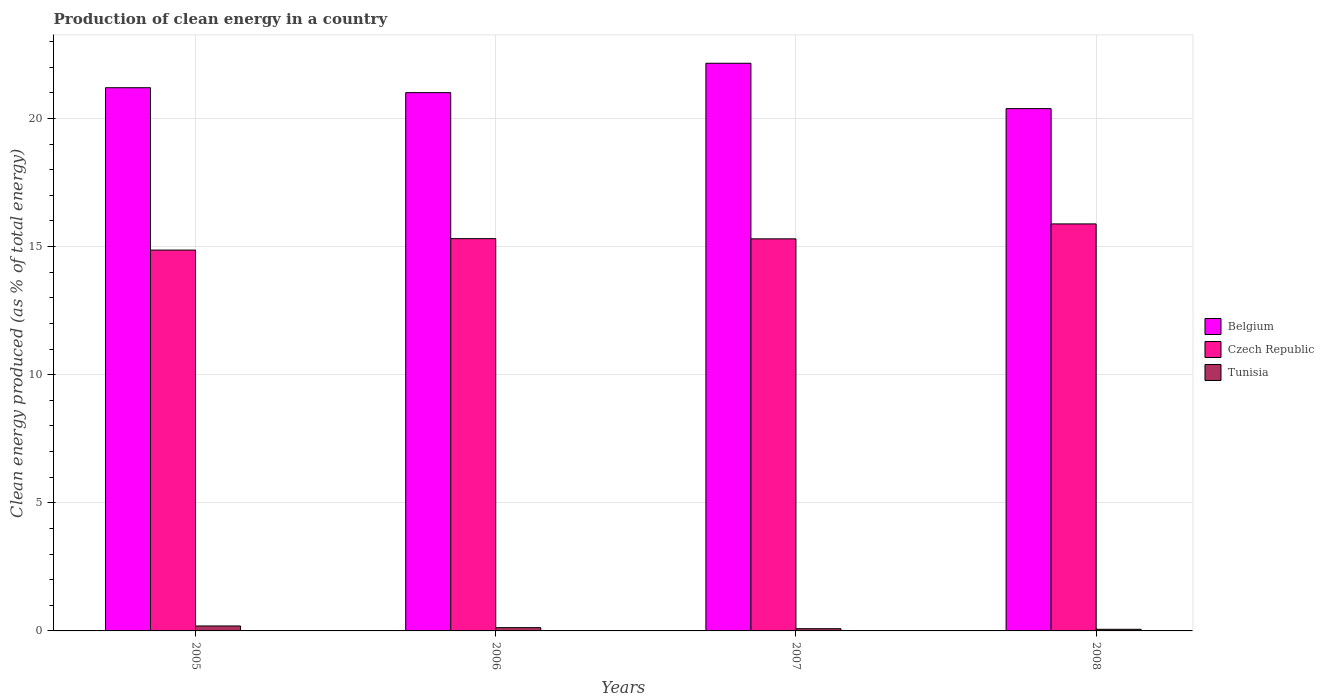How many different coloured bars are there?
Provide a short and direct response. 3. In how many cases, is the number of bars for a given year not equal to the number of legend labels?
Offer a very short reply. 0. What is the percentage of clean energy produced in Tunisia in 2005?
Your answer should be very brief. 0.19. Across all years, what is the maximum percentage of clean energy produced in Belgium?
Ensure brevity in your answer.  22.15. Across all years, what is the minimum percentage of clean energy produced in Tunisia?
Ensure brevity in your answer.  0.06. In which year was the percentage of clean energy produced in Belgium minimum?
Your answer should be compact. 2008. What is the total percentage of clean energy produced in Tunisia in the graph?
Ensure brevity in your answer.  0.47. What is the difference between the percentage of clean energy produced in Tunisia in 2006 and that in 2008?
Make the answer very short. 0.06. What is the difference between the percentage of clean energy produced in Belgium in 2008 and the percentage of clean energy produced in Tunisia in 2007?
Provide a succinct answer. 20.3. What is the average percentage of clean energy produced in Czech Republic per year?
Provide a short and direct response. 15.34. In the year 2005, what is the difference between the percentage of clean energy produced in Czech Republic and percentage of clean energy produced in Belgium?
Keep it short and to the point. -6.34. What is the ratio of the percentage of clean energy produced in Czech Republic in 2005 to that in 2008?
Provide a short and direct response. 0.94. Is the percentage of clean energy produced in Czech Republic in 2006 less than that in 2007?
Offer a very short reply. No. Is the difference between the percentage of clean energy produced in Czech Republic in 2006 and 2007 greater than the difference between the percentage of clean energy produced in Belgium in 2006 and 2007?
Your answer should be very brief. Yes. What is the difference between the highest and the second highest percentage of clean energy produced in Belgium?
Ensure brevity in your answer.  0.96. What is the difference between the highest and the lowest percentage of clean energy produced in Belgium?
Provide a succinct answer. 1.77. Is the sum of the percentage of clean energy produced in Czech Republic in 2007 and 2008 greater than the maximum percentage of clean energy produced in Tunisia across all years?
Your answer should be very brief. Yes. What does the 3rd bar from the left in 2008 represents?
Ensure brevity in your answer.  Tunisia. What does the 3rd bar from the right in 2007 represents?
Your answer should be compact. Belgium. How many bars are there?
Offer a very short reply. 12. How many years are there in the graph?
Your answer should be compact. 4. Does the graph contain any zero values?
Offer a very short reply. No. Does the graph contain grids?
Provide a succinct answer. Yes. What is the title of the graph?
Provide a succinct answer. Production of clean energy in a country. Does "Nepal" appear as one of the legend labels in the graph?
Make the answer very short. No. What is the label or title of the X-axis?
Provide a short and direct response. Years. What is the label or title of the Y-axis?
Keep it short and to the point. Clean energy produced (as % of total energy). What is the Clean energy produced (as % of total energy) of Belgium in 2005?
Make the answer very short. 21.2. What is the Clean energy produced (as % of total energy) of Czech Republic in 2005?
Offer a terse response. 14.86. What is the Clean energy produced (as % of total energy) of Tunisia in 2005?
Ensure brevity in your answer.  0.19. What is the Clean energy produced (as % of total energy) of Belgium in 2006?
Your response must be concise. 21.01. What is the Clean energy produced (as % of total energy) of Czech Republic in 2006?
Keep it short and to the point. 15.31. What is the Clean energy produced (as % of total energy) in Tunisia in 2006?
Your response must be concise. 0.13. What is the Clean energy produced (as % of total energy) of Belgium in 2007?
Offer a terse response. 22.15. What is the Clean energy produced (as % of total energy) in Czech Republic in 2007?
Your answer should be compact. 15.3. What is the Clean energy produced (as % of total energy) of Tunisia in 2007?
Offer a terse response. 0.09. What is the Clean energy produced (as % of total energy) of Belgium in 2008?
Your response must be concise. 20.38. What is the Clean energy produced (as % of total energy) in Czech Republic in 2008?
Provide a short and direct response. 15.88. What is the Clean energy produced (as % of total energy) of Tunisia in 2008?
Offer a terse response. 0.06. Across all years, what is the maximum Clean energy produced (as % of total energy) of Belgium?
Provide a succinct answer. 22.15. Across all years, what is the maximum Clean energy produced (as % of total energy) in Czech Republic?
Your answer should be compact. 15.88. Across all years, what is the maximum Clean energy produced (as % of total energy) in Tunisia?
Your answer should be compact. 0.19. Across all years, what is the minimum Clean energy produced (as % of total energy) of Belgium?
Offer a terse response. 20.38. Across all years, what is the minimum Clean energy produced (as % of total energy) of Czech Republic?
Give a very brief answer. 14.86. Across all years, what is the minimum Clean energy produced (as % of total energy) in Tunisia?
Make the answer very short. 0.06. What is the total Clean energy produced (as % of total energy) of Belgium in the graph?
Your answer should be compact. 84.75. What is the total Clean energy produced (as % of total energy) of Czech Republic in the graph?
Offer a very short reply. 61.36. What is the total Clean energy produced (as % of total energy) in Tunisia in the graph?
Your response must be concise. 0.47. What is the difference between the Clean energy produced (as % of total energy) in Belgium in 2005 and that in 2006?
Offer a very short reply. 0.19. What is the difference between the Clean energy produced (as % of total energy) of Czech Republic in 2005 and that in 2006?
Make the answer very short. -0.45. What is the difference between the Clean energy produced (as % of total energy) of Tunisia in 2005 and that in 2006?
Offer a very short reply. 0.07. What is the difference between the Clean energy produced (as % of total energy) in Belgium in 2005 and that in 2007?
Provide a short and direct response. -0.96. What is the difference between the Clean energy produced (as % of total energy) of Czech Republic in 2005 and that in 2007?
Provide a short and direct response. -0.44. What is the difference between the Clean energy produced (as % of total energy) in Tunisia in 2005 and that in 2007?
Give a very brief answer. 0.11. What is the difference between the Clean energy produced (as % of total energy) of Belgium in 2005 and that in 2008?
Your answer should be compact. 0.81. What is the difference between the Clean energy produced (as % of total energy) in Czech Republic in 2005 and that in 2008?
Provide a short and direct response. -1.02. What is the difference between the Clean energy produced (as % of total energy) of Tunisia in 2005 and that in 2008?
Keep it short and to the point. 0.13. What is the difference between the Clean energy produced (as % of total energy) of Belgium in 2006 and that in 2007?
Provide a short and direct response. -1.15. What is the difference between the Clean energy produced (as % of total energy) of Czech Republic in 2006 and that in 2007?
Offer a terse response. 0.01. What is the difference between the Clean energy produced (as % of total energy) of Tunisia in 2006 and that in 2007?
Offer a very short reply. 0.04. What is the difference between the Clean energy produced (as % of total energy) of Belgium in 2006 and that in 2008?
Make the answer very short. 0.62. What is the difference between the Clean energy produced (as % of total energy) of Czech Republic in 2006 and that in 2008?
Offer a terse response. -0.57. What is the difference between the Clean energy produced (as % of total energy) of Tunisia in 2006 and that in 2008?
Offer a terse response. 0.06. What is the difference between the Clean energy produced (as % of total energy) in Belgium in 2007 and that in 2008?
Make the answer very short. 1.77. What is the difference between the Clean energy produced (as % of total energy) of Czech Republic in 2007 and that in 2008?
Your answer should be very brief. -0.58. What is the difference between the Clean energy produced (as % of total energy) in Tunisia in 2007 and that in 2008?
Offer a terse response. 0.02. What is the difference between the Clean energy produced (as % of total energy) of Belgium in 2005 and the Clean energy produced (as % of total energy) of Czech Republic in 2006?
Your answer should be compact. 5.89. What is the difference between the Clean energy produced (as % of total energy) of Belgium in 2005 and the Clean energy produced (as % of total energy) of Tunisia in 2006?
Make the answer very short. 21.07. What is the difference between the Clean energy produced (as % of total energy) of Czech Republic in 2005 and the Clean energy produced (as % of total energy) of Tunisia in 2006?
Offer a very short reply. 14.74. What is the difference between the Clean energy produced (as % of total energy) in Belgium in 2005 and the Clean energy produced (as % of total energy) in Czech Republic in 2007?
Give a very brief answer. 5.9. What is the difference between the Clean energy produced (as % of total energy) of Belgium in 2005 and the Clean energy produced (as % of total energy) of Tunisia in 2007?
Provide a short and direct response. 21.11. What is the difference between the Clean energy produced (as % of total energy) of Czech Republic in 2005 and the Clean energy produced (as % of total energy) of Tunisia in 2007?
Your response must be concise. 14.78. What is the difference between the Clean energy produced (as % of total energy) in Belgium in 2005 and the Clean energy produced (as % of total energy) in Czech Republic in 2008?
Offer a terse response. 5.32. What is the difference between the Clean energy produced (as % of total energy) of Belgium in 2005 and the Clean energy produced (as % of total energy) of Tunisia in 2008?
Your response must be concise. 21.14. What is the difference between the Clean energy produced (as % of total energy) of Czech Republic in 2005 and the Clean energy produced (as % of total energy) of Tunisia in 2008?
Offer a very short reply. 14.8. What is the difference between the Clean energy produced (as % of total energy) of Belgium in 2006 and the Clean energy produced (as % of total energy) of Czech Republic in 2007?
Offer a very short reply. 5.71. What is the difference between the Clean energy produced (as % of total energy) in Belgium in 2006 and the Clean energy produced (as % of total energy) in Tunisia in 2007?
Your answer should be compact. 20.92. What is the difference between the Clean energy produced (as % of total energy) of Czech Republic in 2006 and the Clean energy produced (as % of total energy) of Tunisia in 2007?
Offer a terse response. 15.22. What is the difference between the Clean energy produced (as % of total energy) of Belgium in 2006 and the Clean energy produced (as % of total energy) of Czech Republic in 2008?
Make the answer very short. 5.12. What is the difference between the Clean energy produced (as % of total energy) in Belgium in 2006 and the Clean energy produced (as % of total energy) in Tunisia in 2008?
Ensure brevity in your answer.  20.95. What is the difference between the Clean energy produced (as % of total energy) of Czech Republic in 2006 and the Clean energy produced (as % of total energy) of Tunisia in 2008?
Your response must be concise. 15.25. What is the difference between the Clean energy produced (as % of total energy) in Belgium in 2007 and the Clean energy produced (as % of total energy) in Czech Republic in 2008?
Keep it short and to the point. 6.27. What is the difference between the Clean energy produced (as % of total energy) of Belgium in 2007 and the Clean energy produced (as % of total energy) of Tunisia in 2008?
Provide a short and direct response. 22.09. What is the difference between the Clean energy produced (as % of total energy) in Czech Republic in 2007 and the Clean energy produced (as % of total energy) in Tunisia in 2008?
Give a very brief answer. 15.24. What is the average Clean energy produced (as % of total energy) in Belgium per year?
Offer a very short reply. 21.19. What is the average Clean energy produced (as % of total energy) in Czech Republic per year?
Your answer should be very brief. 15.34. What is the average Clean energy produced (as % of total energy) in Tunisia per year?
Offer a terse response. 0.12. In the year 2005, what is the difference between the Clean energy produced (as % of total energy) in Belgium and Clean energy produced (as % of total energy) in Czech Republic?
Your answer should be compact. 6.34. In the year 2005, what is the difference between the Clean energy produced (as % of total energy) in Belgium and Clean energy produced (as % of total energy) in Tunisia?
Your answer should be very brief. 21.01. In the year 2005, what is the difference between the Clean energy produced (as % of total energy) in Czech Republic and Clean energy produced (as % of total energy) in Tunisia?
Provide a succinct answer. 14.67. In the year 2006, what is the difference between the Clean energy produced (as % of total energy) in Belgium and Clean energy produced (as % of total energy) in Czech Republic?
Make the answer very short. 5.7. In the year 2006, what is the difference between the Clean energy produced (as % of total energy) in Belgium and Clean energy produced (as % of total energy) in Tunisia?
Offer a very short reply. 20.88. In the year 2006, what is the difference between the Clean energy produced (as % of total energy) in Czech Republic and Clean energy produced (as % of total energy) in Tunisia?
Make the answer very short. 15.18. In the year 2007, what is the difference between the Clean energy produced (as % of total energy) of Belgium and Clean energy produced (as % of total energy) of Czech Republic?
Make the answer very short. 6.85. In the year 2007, what is the difference between the Clean energy produced (as % of total energy) of Belgium and Clean energy produced (as % of total energy) of Tunisia?
Keep it short and to the point. 22.07. In the year 2007, what is the difference between the Clean energy produced (as % of total energy) of Czech Republic and Clean energy produced (as % of total energy) of Tunisia?
Provide a short and direct response. 15.21. In the year 2008, what is the difference between the Clean energy produced (as % of total energy) of Belgium and Clean energy produced (as % of total energy) of Czech Republic?
Keep it short and to the point. 4.5. In the year 2008, what is the difference between the Clean energy produced (as % of total energy) in Belgium and Clean energy produced (as % of total energy) in Tunisia?
Your answer should be compact. 20.32. In the year 2008, what is the difference between the Clean energy produced (as % of total energy) in Czech Republic and Clean energy produced (as % of total energy) in Tunisia?
Provide a short and direct response. 15.82. What is the ratio of the Clean energy produced (as % of total energy) in Belgium in 2005 to that in 2006?
Offer a very short reply. 1.01. What is the ratio of the Clean energy produced (as % of total energy) of Czech Republic in 2005 to that in 2006?
Offer a very short reply. 0.97. What is the ratio of the Clean energy produced (as % of total energy) of Tunisia in 2005 to that in 2006?
Offer a terse response. 1.51. What is the ratio of the Clean energy produced (as % of total energy) in Belgium in 2005 to that in 2007?
Make the answer very short. 0.96. What is the ratio of the Clean energy produced (as % of total energy) in Czech Republic in 2005 to that in 2007?
Offer a very short reply. 0.97. What is the ratio of the Clean energy produced (as % of total energy) in Tunisia in 2005 to that in 2007?
Provide a short and direct response. 2.21. What is the ratio of the Clean energy produced (as % of total energy) of Belgium in 2005 to that in 2008?
Ensure brevity in your answer.  1.04. What is the ratio of the Clean energy produced (as % of total energy) in Czech Republic in 2005 to that in 2008?
Provide a succinct answer. 0.94. What is the ratio of the Clean energy produced (as % of total energy) in Tunisia in 2005 to that in 2008?
Provide a succinct answer. 3.07. What is the ratio of the Clean energy produced (as % of total energy) in Belgium in 2006 to that in 2007?
Make the answer very short. 0.95. What is the ratio of the Clean energy produced (as % of total energy) in Czech Republic in 2006 to that in 2007?
Offer a very short reply. 1. What is the ratio of the Clean energy produced (as % of total energy) in Tunisia in 2006 to that in 2007?
Your answer should be very brief. 1.46. What is the ratio of the Clean energy produced (as % of total energy) of Belgium in 2006 to that in 2008?
Ensure brevity in your answer.  1.03. What is the ratio of the Clean energy produced (as % of total energy) in Czech Republic in 2006 to that in 2008?
Provide a succinct answer. 0.96. What is the ratio of the Clean energy produced (as % of total energy) in Tunisia in 2006 to that in 2008?
Offer a terse response. 2.03. What is the ratio of the Clean energy produced (as % of total energy) of Belgium in 2007 to that in 2008?
Provide a succinct answer. 1.09. What is the ratio of the Clean energy produced (as % of total energy) in Czech Republic in 2007 to that in 2008?
Provide a succinct answer. 0.96. What is the ratio of the Clean energy produced (as % of total energy) of Tunisia in 2007 to that in 2008?
Provide a short and direct response. 1.39. What is the difference between the highest and the second highest Clean energy produced (as % of total energy) in Belgium?
Your answer should be compact. 0.96. What is the difference between the highest and the second highest Clean energy produced (as % of total energy) of Czech Republic?
Give a very brief answer. 0.57. What is the difference between the highest and the second highest Clean energy produced (as % of total energy) in Tunisia?
Make the answer very short. 0.07. What is the difference between the highest and the lowest Clean energy produced (as % of total energy) in Belgium?
Give a very brief answer. 1.77. What is the difference between the highest and the lowest Clean energy produced (as % of total energy) of Czech Republic?
Your answer should be very brief. 1.02. What is the difference between the highest and the lowest Clean energy produced (as % of total energy) of Tunisia?
Ensure brevity in your answer.  0.13. 